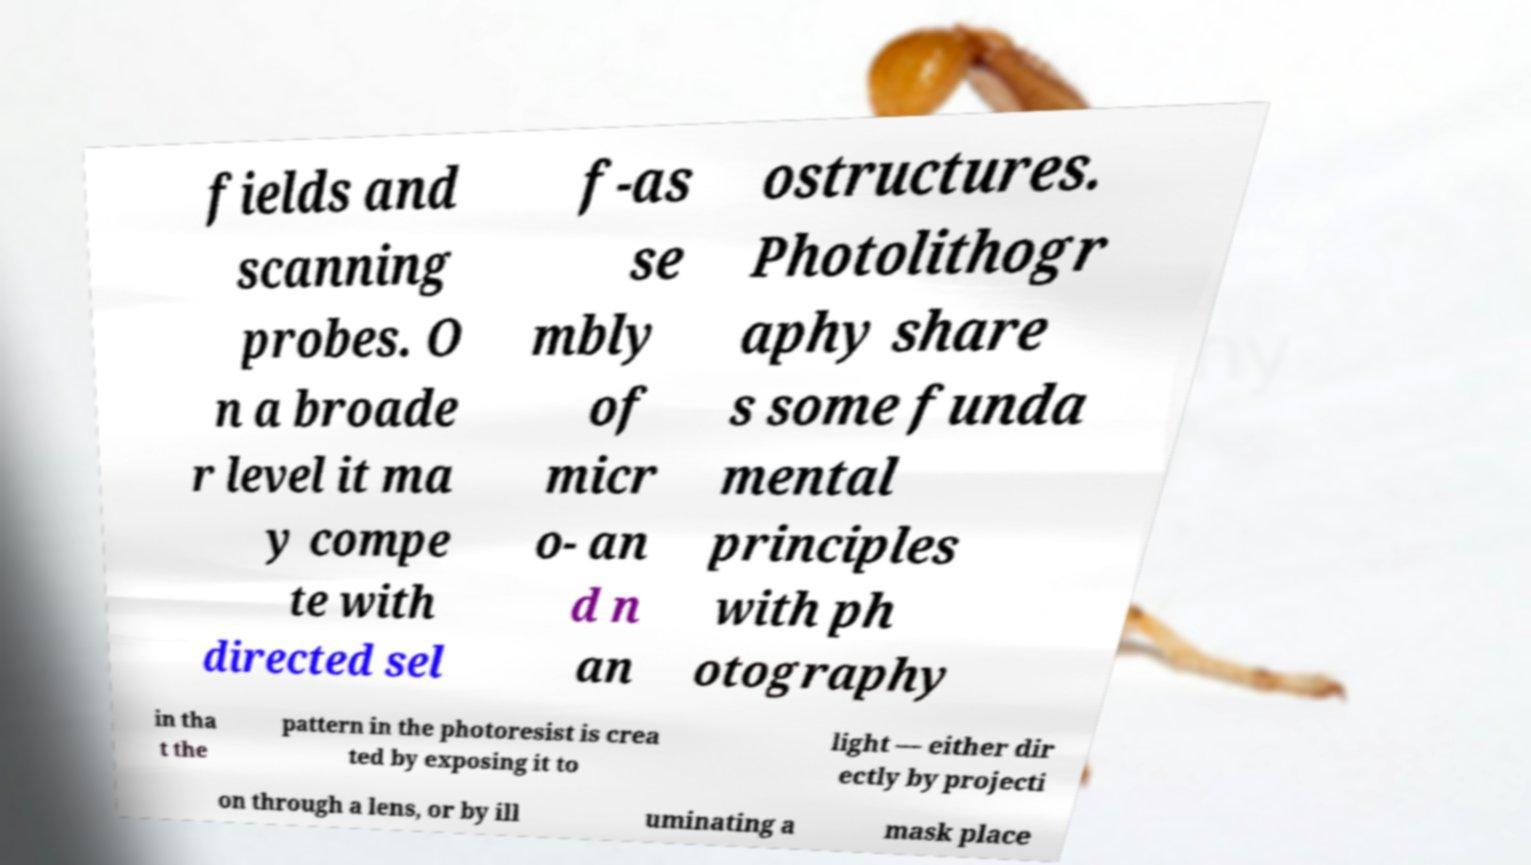There's text embedded in this image that I need extracted. Can you transcribe it verbatim? fields and scanning probes. O n a broade r level it ma y compe te with directed sel f-as se mbly of micr o- an d n an ostructures. Photolithogr aphy share s some funda mental principles with ph otography in tha t the pattern in the photoresist is crea ted by exposing it to light — either dir ectly by projecti on through a lens, or by ill uminating a mask place 